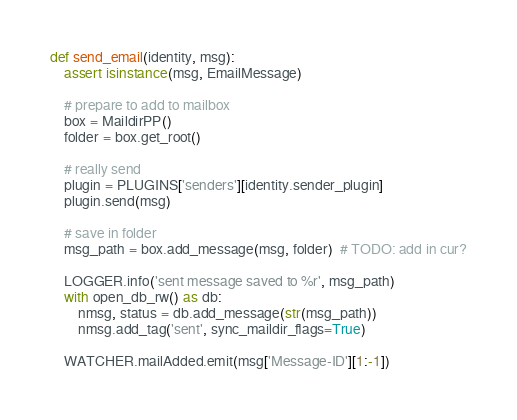<code> <loc_0><loc_0><loc_500><loc_500><_Python_>def send_email(identity, msg):
    assert isinstance(msg, EmailMessage)

    # prepare to add to mailbox
    box = MaildirPP()
    folder = box.get_root()

    # really send
    plugin = PLUGINS['senders'][identity.sender_plugin]
    plugin.send(msg)

    # save in folder
    msg_path = box.add_message(msg, folder)  # TODO: add in cur?

    LOGGER.info('sent message saved to %r', msg_path)
    with open_db_rw() as db:
        nmsg, status = db.add_message(str(msg_path))
        nmsg.add_tag('sent', sync_maildir_flags=True)

    WATCHER.mailAdded.emit(msg['Message-ID'][1:-1])
</code> 